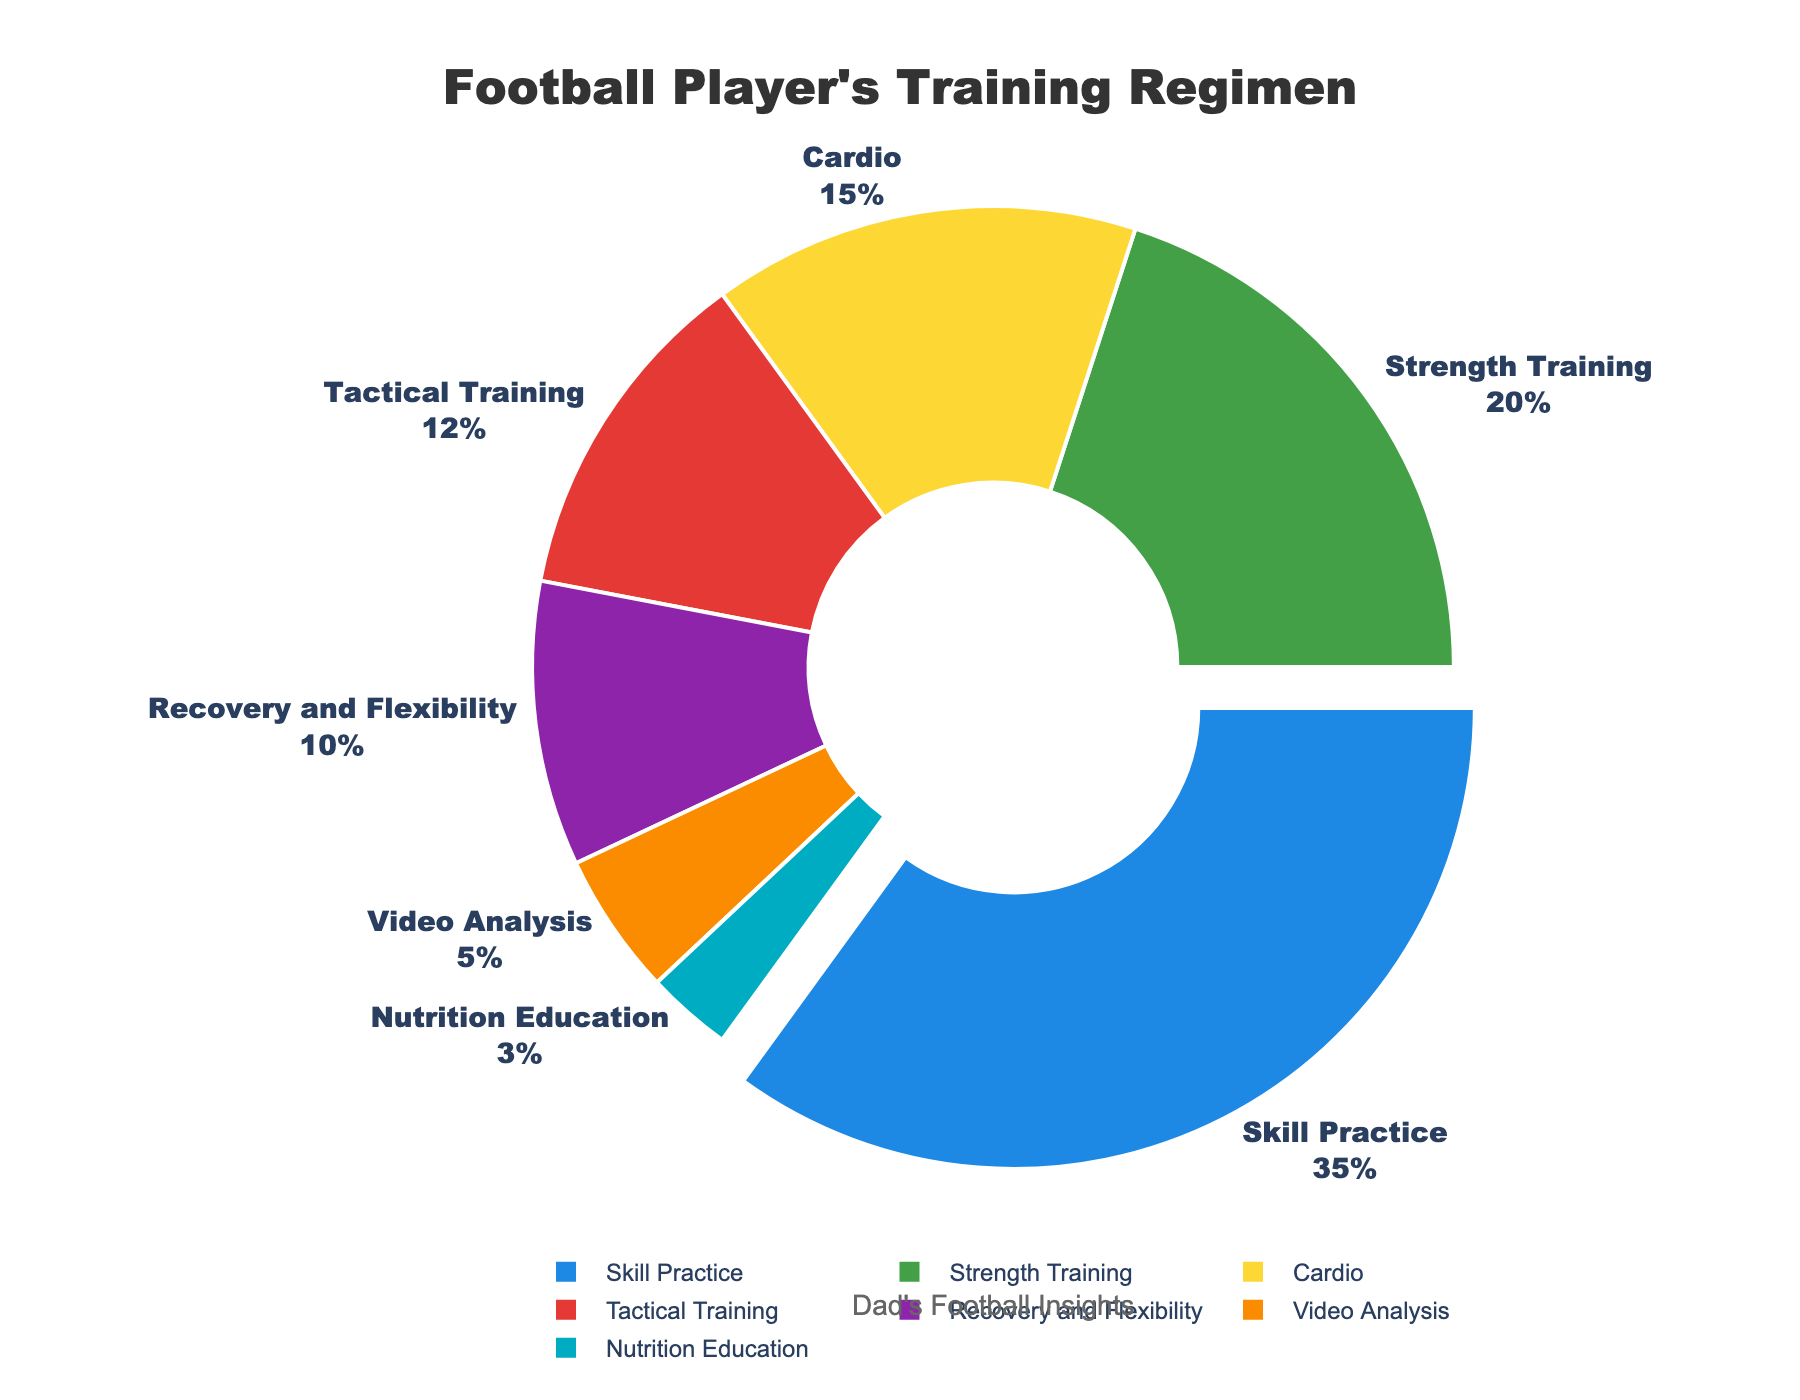Which category takes up the largest percentage of a football player's training regimen? Look for the category with the largest section in the pie chart. The segment with the label "Skill Practice" makes up the largest percentage.
Answer: Skill Practice What is the combined percentage of Tactical Training and Recovery and Flexibility? Add the percentages of Tactical Training (12%) and Recovery and Flexibility (10%). The sum is 12% + 10% = 22%.
Answer: 22% Which category has a smaller percentage, Nutrition Education or Video Analysis? Compare the two categories. Nutrition Education is at 3%, and Video Analysis is at 5%, so Nutrition Education is smaller.
Answer: Nutrition Education Does Cardio take up more or less percentage than Strength Training? Compare the percentages of Cardio (15%) and Strength Training (20%). Cardio is less than Strength Training.
Answer: Less What percentage of the training regimen is devoted to activities other than Skill Practice? Subtract the percentage of Skill Practice (35%) from 100%. The remaining percentage is 100% - 35% = 65%.
Answer: 65% Which activities collectively account for more than 50% of the training regimen? Combine categories until the sum exceeds 50%. Skill Practice (35%) plus Strength Training (20%) results in 55%, which is already more than half.
Answer: Skill Practice and Strength Training If we consider Cardio, Tactical Training, and Recovery and Flexibility together, do they form a larger or smaller portion than Skill Practice alone? Sum the percentages of Cardio, Tactical Training, and Recovery and Flexibility: 15% + 12% + 10% = 37%. Compare this sum to Skill Practice (35%). 37% is larger than 35%.
Answer: Larger What is the smallest category in terms of percentage? Look for the category with the smallest section in the pie chart. Nutrition Education is the smallest, at 3%.
Answer: Nutrition Education What is the total percentage of activities related to physical conditioning (Strength Training, Cardio, and Recovery and Flexibility)? Sum the percentages of Strength Training (20%), Cardio (15%), and Recovery and Flexibility (10%): 20% + 15% + 10% = 45%.
Answer: 45% Is the percentage dedicated to Video Analysis closer to that of Nutrition Education or Tactical Training? Compare the percentages: Video Analysis is 5%, Nutrition Education is 3%, and Tactical Training is 12%. The difference between Video Analysis and Nutrition Education is 2% (5% - 3%), whereas the difference between Video Analysis and Tactical Training is 7% (12% - 5%). Thus, Video Analysis is closer to Nutrition Education.
Answer: Nutrition Education 